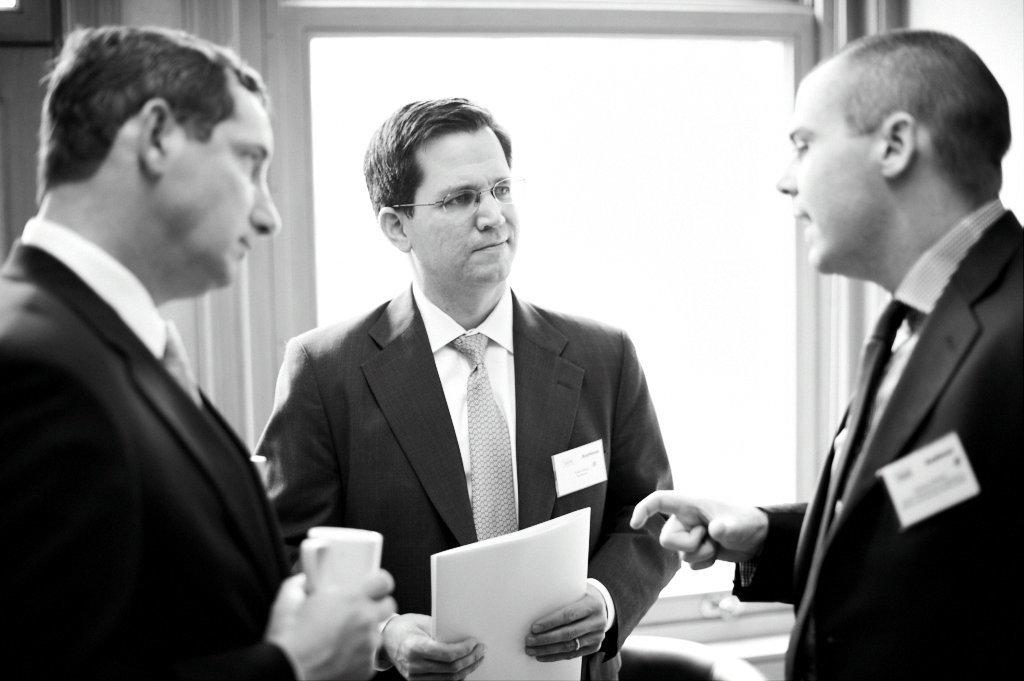What is the color scheme of the image? The image is black and white. How many people are in the image? There are three men in the image. What are the men wearing? The men are wearing suits. What are the men holding in their hands? The men are holding something in their hands. What type of wren can be seen in the image? There is no wren present in the image; it features three men wearing suits in a black and white setting. 